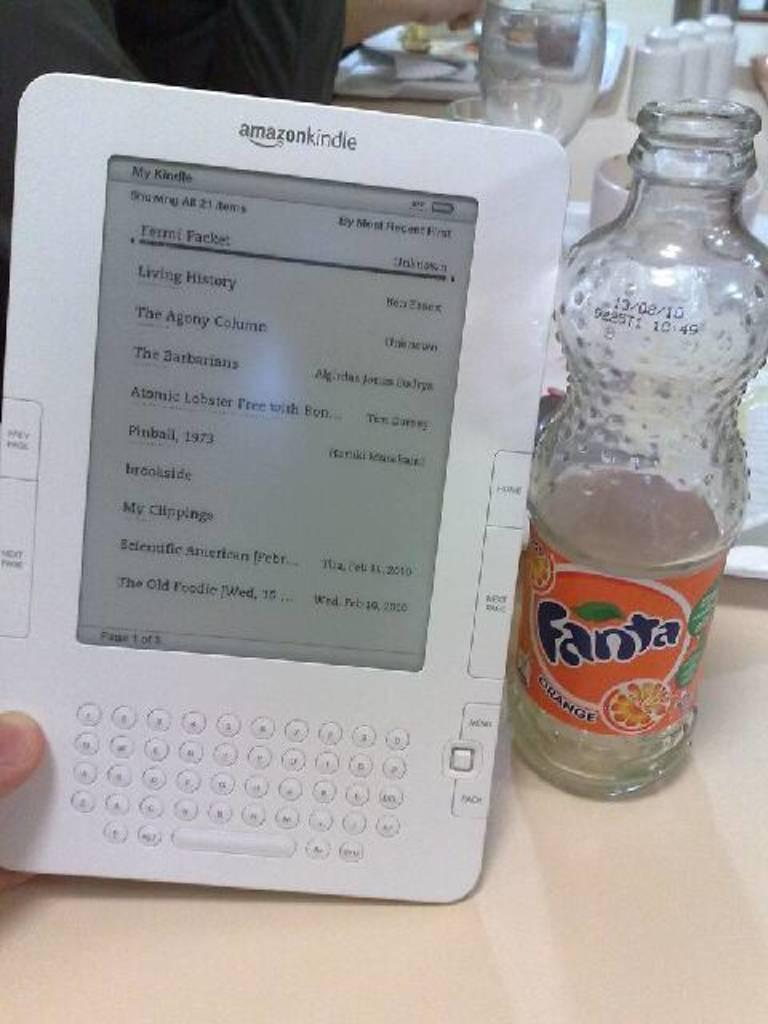<image>
Present a compact description of the photo's key features. A bottle of Fanta is next to an Amazon kindle. 